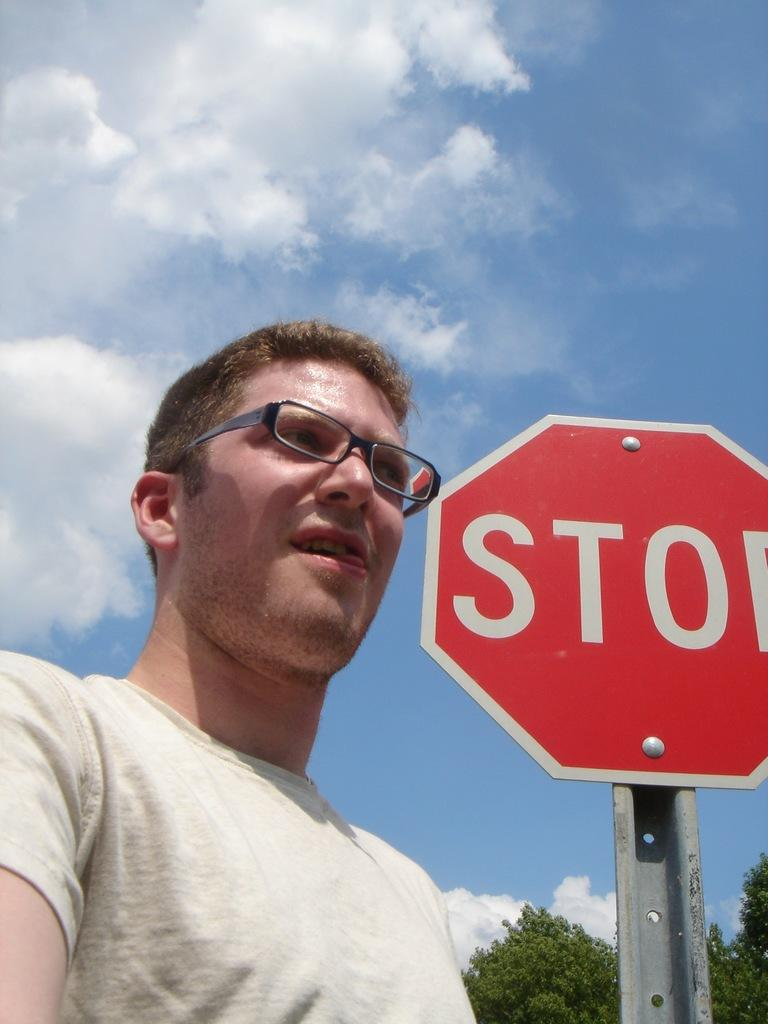Provide a one-sentence caption for the provided image. a man in glasses and red hair in front of a Stop sign. 